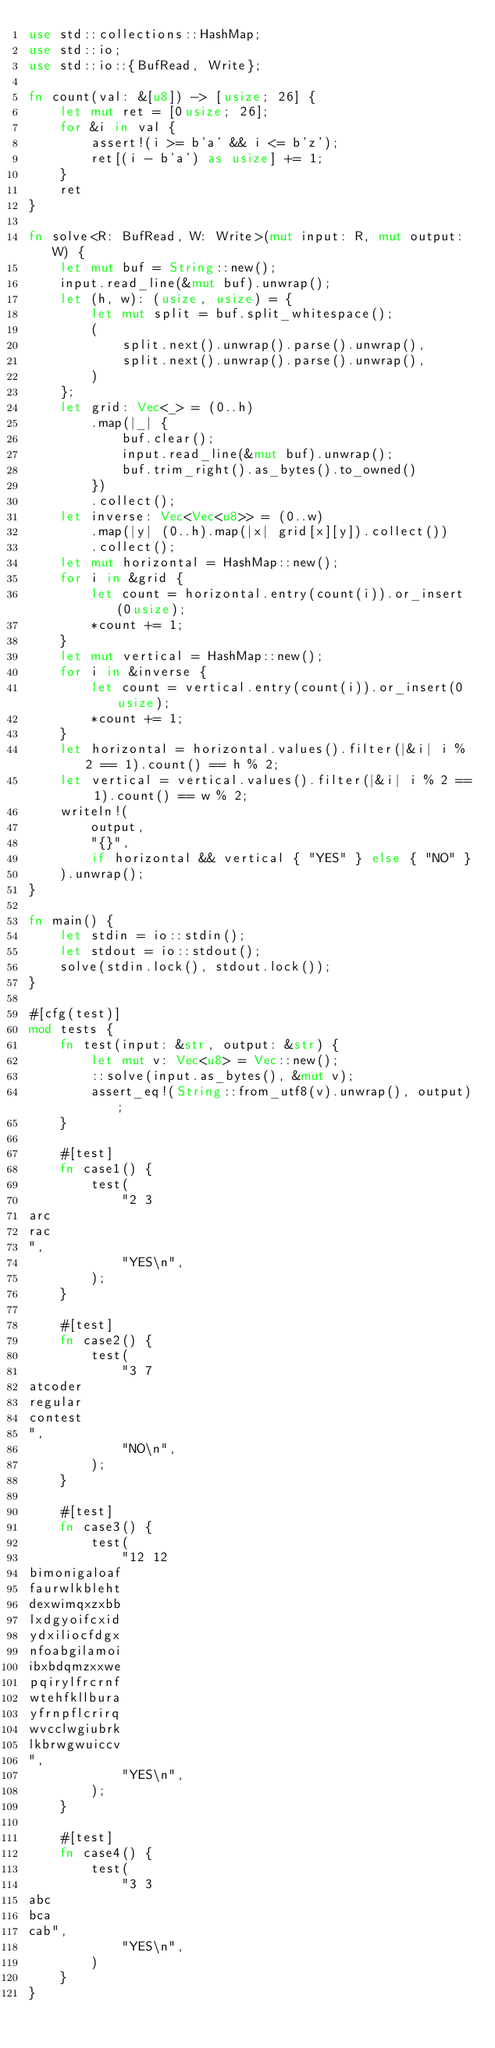<code> <loc_0><loc_0><loc_500><loc_500><_Rust_>use std::collections::HashMap;
use std::io;
use std::io::{BufRead, Write};

fn count(val: &[u8]) -> [usize; 26] {
    let mut ret = [0usize; 26];
    for &i in val {
        assert!(i >= b'a' && i <= b'z');
        ret[(i - b'a') as usize] += 1;
    }
    ret
}

fn solve<R: BufRead, W: Write>(mut input: R, mut output: W) {
    let mut buf = String::new();
    input.read_line(&mut buf).unwrap();
    let (h, w): (usize, usize) = {
        let mut split = buf.split_whitespace();
        (
            split.next().unwrap().parse().unwrap(),
            split.next().unwrap().parse().unwrap(),
        )
    };
    let grid: Vec<_> = (0..h)
        .map(|_| {
            buf.clear();
            input.read_line(&mut buf).unwrap();
            buf.trim_right().as_bytes().to_owned()
        })
        .collect();
    let inverse: Vec<Vec<u8>> = (0..w)
        .map(|y| (0..h).map(|x| grid[x][y]).collect())
        .collect();
    let mut horizontal = HashMap::new();
    for i in &grid {
        let count = horizontal.entry(count(i)).or_insert(0usize);
        *count += 1;
    }
    let mut vertical = HashMap::new();
    for i in &inverse {
        let count = vertical.entry(count(i)).or_insert(0usize);
        *count += 1;
    }
    let horizontal = horizontal.values().filter(|&i| i % 2 == 1).count() == h % 2;
    let vertical = vertical.values().filter(|&i| i % 2 == 1).count() == w % 2;
    writeln!(
        output,
        "{}",
        if horizontal && vertical { "YES" } else { "NO" }
    ).unwrap();
}

fn main() {
    let stdin = io::stdin();
    let stdout = io::stdout();
    solve(stdin.lock(), stdout.lock());
}

#[cfg(test)]
mod tests {
    fn test(input: &str, output: &str) {
        let mut v: Vec<u8> = Vec::new();
        ::solve(input.as_bytes(), &mut v);
        assert_eq!(String::from_utf8(v).unwrap(), output);
    }

    #[test]
    fn case1() {
        test(
            "2 3
arc
rac
",
            "YES\n",
        );
    }

    #[test]
    fn case2() {
        test(
            "3 7
atcoder
regular
contest
",
            "NO\n",
        );
    }

    #[test]
    fn case3() {
        test(
            "12 12
bimonigaloaf
faurwlkbleht
dexwimqxzxbb
lxdgyoifcxid
ydxiliocfdgx
nfoabgilamoi
ibxbdqmzxxwe
pqirylfrcrnf
wtehfkllbura
yfrnpflcrirq
wvcclwgiubrk
lkbrwgwuiccv
",
            "YES\n",
        );
    }

    #[test]
    fn case4() {
        test(
            "3 3
abc
bca
cab",
            "YES\n",
        )
    }
}
</code> 